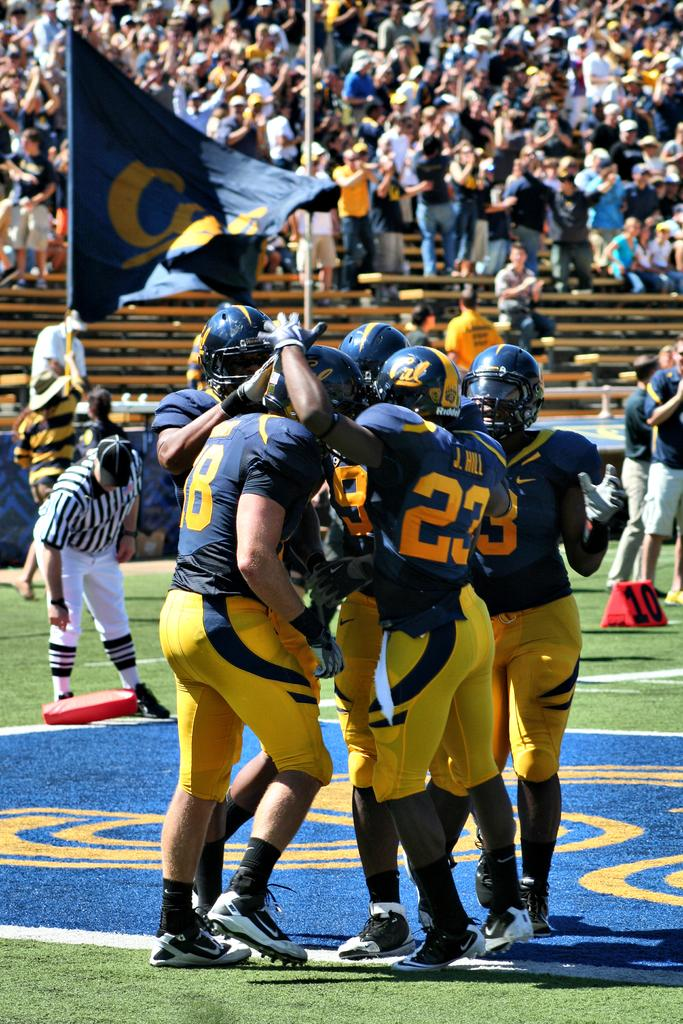What type of location is depicted in the image? The image shows a stadium. What can be seen on the ground in the image? The ground is visible, and there are objects on it. What type of vegetation is present on the ground? Grass is present on the ground. What additional features can be seen in the image? There is a flag and a pole in the image. Where is the object located in the image? There is an object on the left side of the image. What type of disease is being treated in the image? There is no indication of a disease or treatment in the image; it shows a stadium with people, objects, and a flag. What type of belief is being practiced in the image? There is no indication of a belief or practice in the image; it shows a stadium with people, objects, and a flag. 